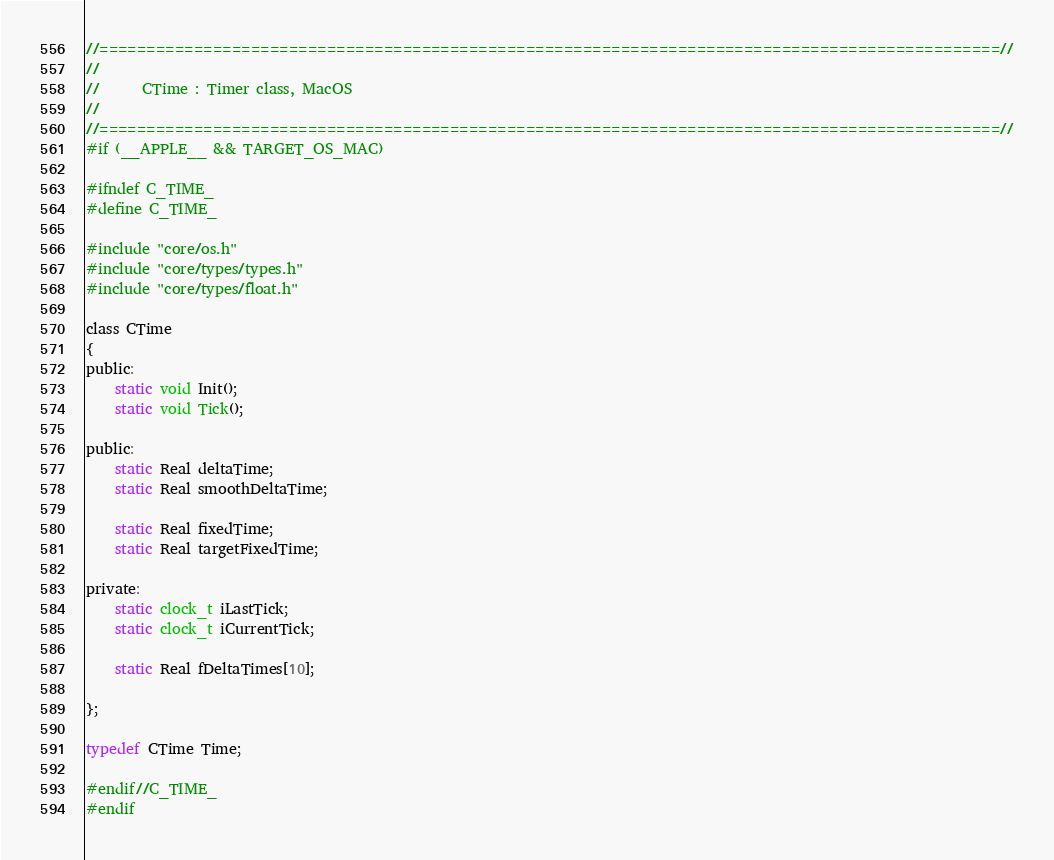<code> <loc_0><loc_0><loc_500><loc_500><_C_>//===============================================================================================//
//
//		CTime : Timer class, MacOS
//
//===============================================================================================//
#if (__APPLE__ && TARGET_OS_MAC)

#ifndef C_TIME_
#define C_TIME_

#include "core/os.h"
#include "core/types/types.h"
#include "core/types/float.h"

class CTime
{
public:
	static void Init();
	static void Tick();

public:
	static Real deltaTime;
	static Real smoothDeltaTime;

	static Real fixedTime;
	static Real targetFixedTime;

private:
	static clock_t iLastTick;
	static clock_t iCurrentTick;

	static Real fDeltaTimes[10];

};

typedef CTime Time;

#endif//C_TIME_
#endif</code> 